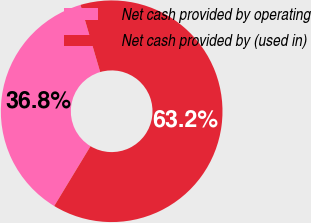<chart> <loc_0><loc_0><loc_500><loc_500><pie_chart><fcel>Net cash provided by operating<fcel>Net cash provided by (used in)<nl><fcel>36.79%<fcel>63.21%<nl></chart> 